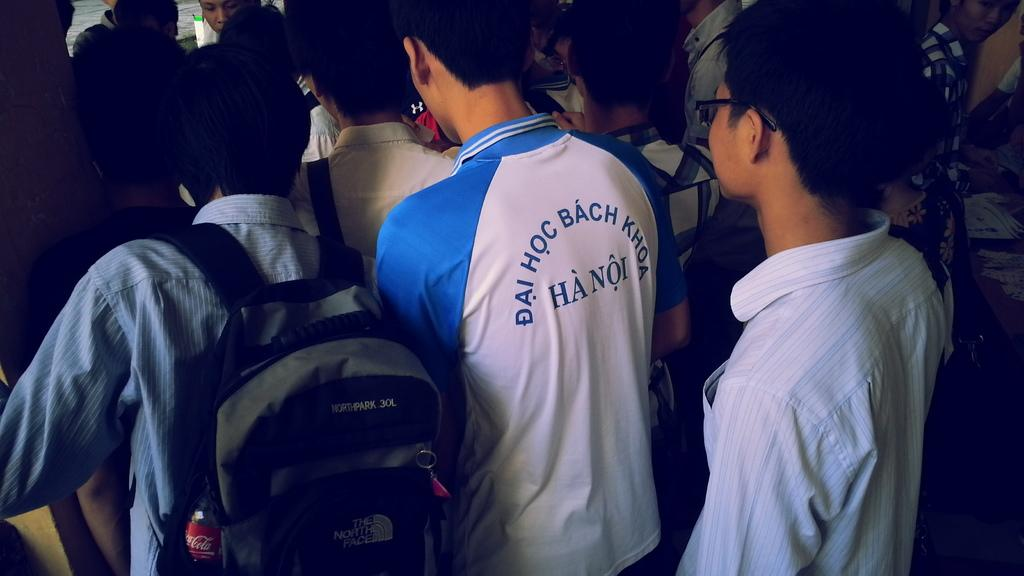<image>
Share a concise interpretation of the image provided. A group of people are seen from behind and one has Hanoi written in Vietnamese on the back. 